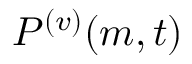<formula> <loc_0><loc_0><loc_500><loc_500>P ^ { ( v ) } ( { m } , { t } )</formula> 